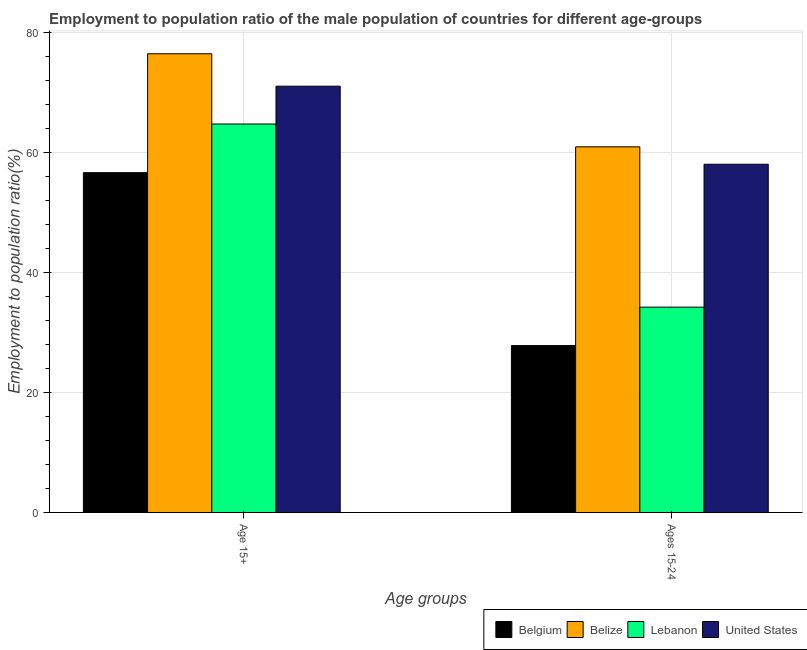How many different coloured bars are there?
Offer a terse response. 4. How many groups of bars are there?
Offer a terse response. 2. Are the number of bars per tick equal to the number of legend labels?
Keep it short and to the point. Yes. How many bars are there on the 1st tick from the left?
Provide a short and direct response. 4. What is the label of the 2nd group of bars from the left?
Offer a very short reply. Ages 15-24. What is the employment to population ratio(age 15+) in Belgium?
Provide a succinct answer. 56.6. Across all countries, what is the maximum employment to population ratio(age 15-24)?
Your response must be concise. 60.9. Across all countries, what is the minimum employment to population ratio(age 15-24)?
Your answer should be very brief. 27.8. In which country was the employment to population ratio(age 15-24) maximum?
Make the answer very short. Belize. In which country was the employment to population ratio(age 15+) minimum?
Ensure brevity in your answer.  Belgium. What is the total employment to population ratio(age 15-24) in the graph?
Your answer should be compact. 180.9. What is the difference between the employment to population ratio(age 15+) in Belize and that in Belgium?
Offer a very short reply. 19.8. What is the difference between the employment to population ratio(age 15-24) in Lebanon and the employment to population ratio(age 15+) in United States?
Provide a succinct answer. -36.8. What is the average employment to population ratio(age 15+) per country?
Provide a succinct answer. 67.17. What is the difference between the employment to population ratio(age 15+) and employment to population ratio(age 15-24) in Belgium?
Make the answer very short. 28.8. What is the ratio of the employment to population ratio(age 15-24) in Belgium to that in United States?
Provide a succinct answer. 0.48. In how many countries, is the employment to population ratio(age 15+) greater than the average employment to population ratio(age 15+) taken over all countries?
Your answer should be very brief. 2. What does the 1st bar from the left in Ages 15-24 represents?
Your answer should be compact. Belgium. How many bars are there?
Offer a very short reply. 8. Are all the bars in the graph horizontal?
Provide a succinct answer. No. How many countries are there in the graph?
Your answer should be compact. 4. Are the values on the major ticks of Y-axis written in scientific E-notation?
Ensure brevity in your answer.  No. Does the graph contain any zero values?
Offer a terse response. No. How many legend labels are there?
Offer a very short reply. 4. How are the legend labels stacked?
Offer a very short reply. Horizontal. What is the title of the graph?
Offer a terse response. Employment to population ratio of the male population of countries for different age-groups. Does "French Polynesia" appear as one of the legend labels in the graph?
Ensure brevity in your answer.  No. What is the label or title of the X-axis?
Offer a very short reply. Age groups. What is the Employment to population ratio(%) of Belgium in Age 15+?
Your response must be concise. 56.6. What is the Employment to population ratio(%) of Belize in Age 15+?
Keep it short and to the point. 76.4. What is the Employment to population ratio(%) of Lebanon in Age 15+?
Make the answer very short. 64.7. What is the Employment to population ratio(%) of United States in Age 15+?
Offer a very short reply. 71. What is the Employment to population ratio(%) in Belgium in Ages 15-24?
Provide a short and direct response. 27.8. What is the Employment to population ratio(%) in Belize in Ages 15-24?
Ensure brevity in your answer.  60.9. What is the Employment to population ratio(%) of Lebanon in Ages 15-24?
Make the answer very short. 34.2. Across all Age groups, what is the maximum Employment to population ratio(%) in Belgium?
Your response must be concise. 56.6. Across all Age groups, what is the maximum Employment to population ratio(%) of Belize?
Provide a short and direct response. 76.4. Across all Age groups, what is the maximum Employment to population ratio(%) of Lebanon?
Offer a very short reply. 64.7. Across all Age groups, what is the minimum Employment to population ratio(%) in Belgium?
Offer a very short reply. 27.8. Across all Age groups, what is the minimum Employment to population ratio(%) of Belize?
Provide a succinct answer. 60.9. Across all Age groups, what is the minimum Employment to population ratio(%) of Lebanon?
Make the answer very short. 34.2. Across all Age groups, what is the minimum Employment to population ratio(%) of United States?
Your answer should be compact. 58. What is the total Employment to population ratio(%) in Belgium in the graph?
Offer a terse response. 84.4. What is the total Employment to population ratio(%) of Belize in the graph?
Provide a short and direct response. 137.3. What is the total Employment to population ratio(%) of Lebanon in the graph?
Ensure brevity in your answer.  98.9. What is the total Employment to population ratio(%) of United States in the graph?
Keep it short and to the point. 129. What is the difference between the Employment to population ratio(%) in Belgium in Age 15+ and that in Ages 15-24?
Provide a succinct answer. 28.8. What is the difference between the Employment to population ratio(%) of Belize in Age 15+ and that in Ages 15-24?
Your answer should be very brief. 15.5. What is the difference between the Employment to population ratio(%) in Lebanon in Age 15+ and that in Ages 15-24?
Provide a short and direct response. 30.5. What is the difference between the Employment to population ratio(%) of Belgium in Age 15+ and the Employment to population ratio(%) of Belize in Ages 15-24?
Your response must be concise. -4.3. What is the difference between the Employment to population ratio(%) of Belgium in Age 15+ and the Employment to population ratio(%) of Lebanon in Ages 15-24?
Provide a succinct answer. 22.4. What is the difference between the Employment to population ratio(%) in Belize in Age 15+ and the Employment to population ratio(%) in Lebanon in Ages 15-24?
Offer a very short reply. 42.2. What is the difference between the Employment to population ratio(%) of Belize in Age 15+ and the Employment to population ratio(%) of United States in Ages 15-24?
Provide a succinct answer. 18.4. What is the average Employment to population ratio(%) of Belgium per Age groups?
Your answer should be compact. 42.2. What is the average Employment to population ratio(%) of Belize per Age groups?
Offer a very short reply. 68.65. What is the average Employment to population ratio(%) of Lebanon per Age groups?
Your answer should be very brief. 49.45. What is the average Employment to population ratio(%) in United States per Age groups?
Give a very brief answer. 64.5. What is the difference between the Employment to population ratio(%) in Belgium and Employment to population ratio(%) in Belize in Age 15+?
Give a very brief answer. -19.8. What is the difference between the Employment to population ratio(%) in Belgium and Employment to population ratio(%) in Lebanon in Age 15+?
Provide a short and direct response. -8.1. What is the difference between the Employment to population ratio(%) of Belgium and Employment to population ratio(%) of United States in Age 15+?
Ensure brevity in your answer.  -14.4. What is the difference between the Employment to population ratio(%) of Belize and Employment to population ratio(%) of United States in Age 15+?
Give a very brief answer. 5.4. What is the difference between the Employment to population ratio(%) in Lebanon and Employment to population ratio(%) in United States in Age 15+?
Offer a very short reply. -6.3. What is the difference between the Employment to population ratio(%) of Belgium and Employment to population ratio(%) of Belize in Ages 15-24?
Your answer should be very brief. -33.1. What is the difference between the Employment to population ratio(%) in Belgium and Employment to population ratio(%) in Lebanon in Ages 15-24?
Your answer should be compact. -6.4. What is the difference between the Employment to population ratio(%) of Belgium and Employment to population ratio(%) of United States in Ages 15-24?
Make the answer very short. -30.2. What is the difference between the Employment to population ratio(%) in Belize and Employment to population ratio(%) in Lebanon in Ages 15-24?
Give a very brief answer. 26.7. What is the difference between the Employment to population ratio(%) of Belize and Employment to population ratio(%) of United States in Ages 15-24?
Your answer should be very brief. 2.9. What is the difference between the Employment to population ratio(%) in Lebanon and Employment to population ratio(%) in United States in Ages 15-24?
Provide a succinct answer. -23.8. What is the ratio of the Employment to population ratio(%) of Belgium in Age 15+ to that in Ages 15-24?
Your answer should be compact. 2.04. What is the ratio of the Employment to population ratio(%) in Belize in Age 15+ to that in Ages 15-24?
Make the answer very short. 1.25. What is the ratio of the Employment to population ratio(%) of Lebanon in Age 15+ to that in Ages 15-24?
Provide a succinct answer. 1.89. What is the ratio of the Employment to population ratio(%) of United States in Age 15+ to that in Ages 15-24?
Offer a terse response. 1.22. What is the difference between the highest and the second highest Employment to population ratio(%) in Belgium?
Offer a terse response. 28.8. What is the difference between the highest and the second highest Employment to population ratio(%) of Lebanon?
Offer a terse response. 30.5. What is the difference between the highest and the second highest Employment to population ratio(%) in United States?
Offer a very short reply. 13. What is the difference between the highest and the lowest Employment to population ratio(%) of Belgium?
Keep it short and to the point. 28.8. What is the difference between the highest and the lowest Employment to population ratio(%) in Belize?
Your answer should be compact. 15.5. What is the difference between the highest and the lowest Employment to population ratio(%) of Lebanon?
Ensure brevity in your answer.  30.5. What is the difference between the highest and the lowest Employment to population ratio(%) in United States?
Your answer should be compact. 13. 